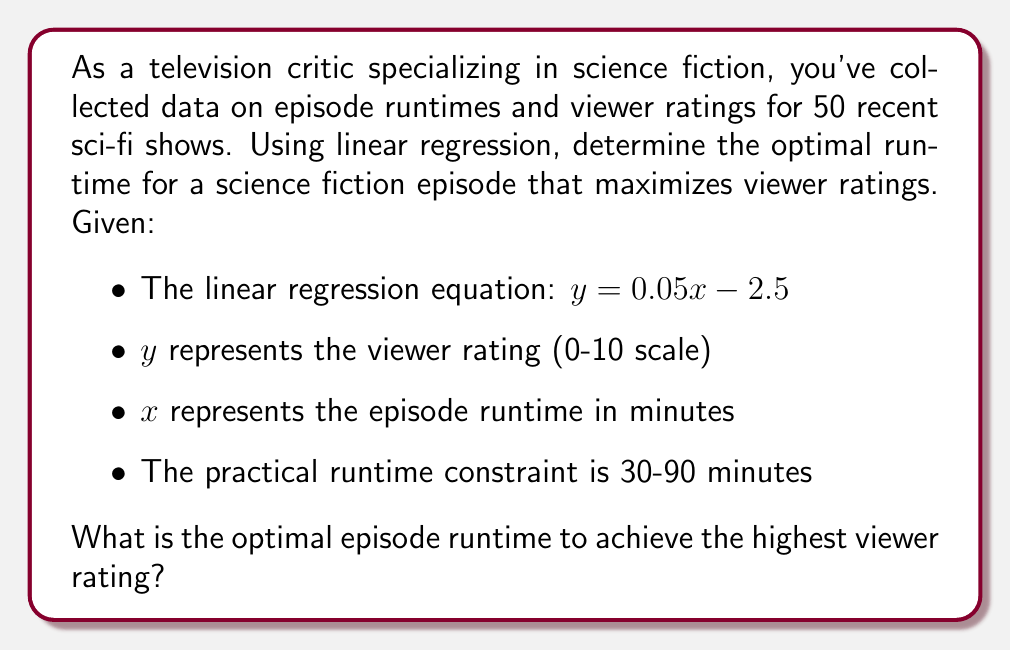Solve this math problem. To solve this problem, we'll follow these steps:

1) The linear regression equation is given as:
   $y = 0.05x - 2.5$

2) Since $y$ represents the viewer rating and $x$ represents the runtime, we want to maximize $y$ within the given constraints.

3) The constraint for $x$ is 30 ≤ $x$ ≤ 90

4) In a linear equation, the maximum value within a range will always occur at one of the endpoints. So, we need to calculate $y$ for both $x = 30$ and $x = 90$:

   For $x = 30$:
   $y = 0.05(30) - 2.5 = 1.5 - 2.5 = -1$

   For $x = 90$:
   $y = 0.05(90) - 2.5 = 4.5 - 2.5 = 2$

5) The larger $y$ value corresponds to $x = 90$, so this is our optimal runtime.

6) To verify, we can calculate the $y$ value for any point between 30 and 90, and it will always be less than 2.

Therefore, within the given constraints, the optimal runtime for a science fiction episode to achieve the highest viewer rating is 90 minutes.
Answer: 90 minutes 